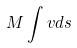<formula> <loc_0><loc_0><loc_500><loc_500>M \int v d s</formula> 